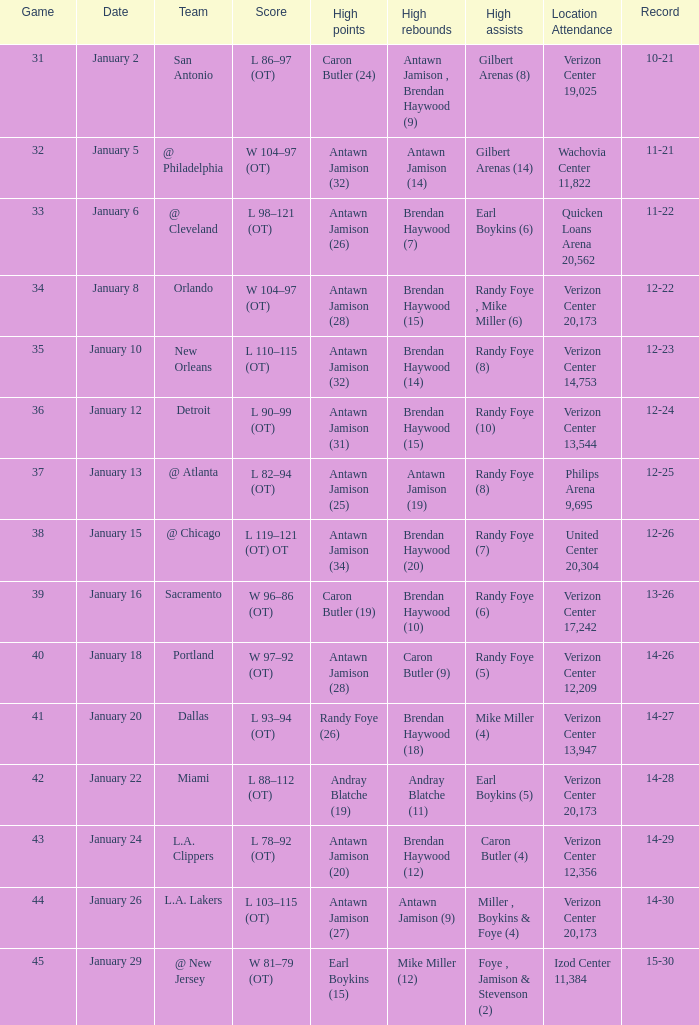How many individuals scored high in game 35? 1.0. 